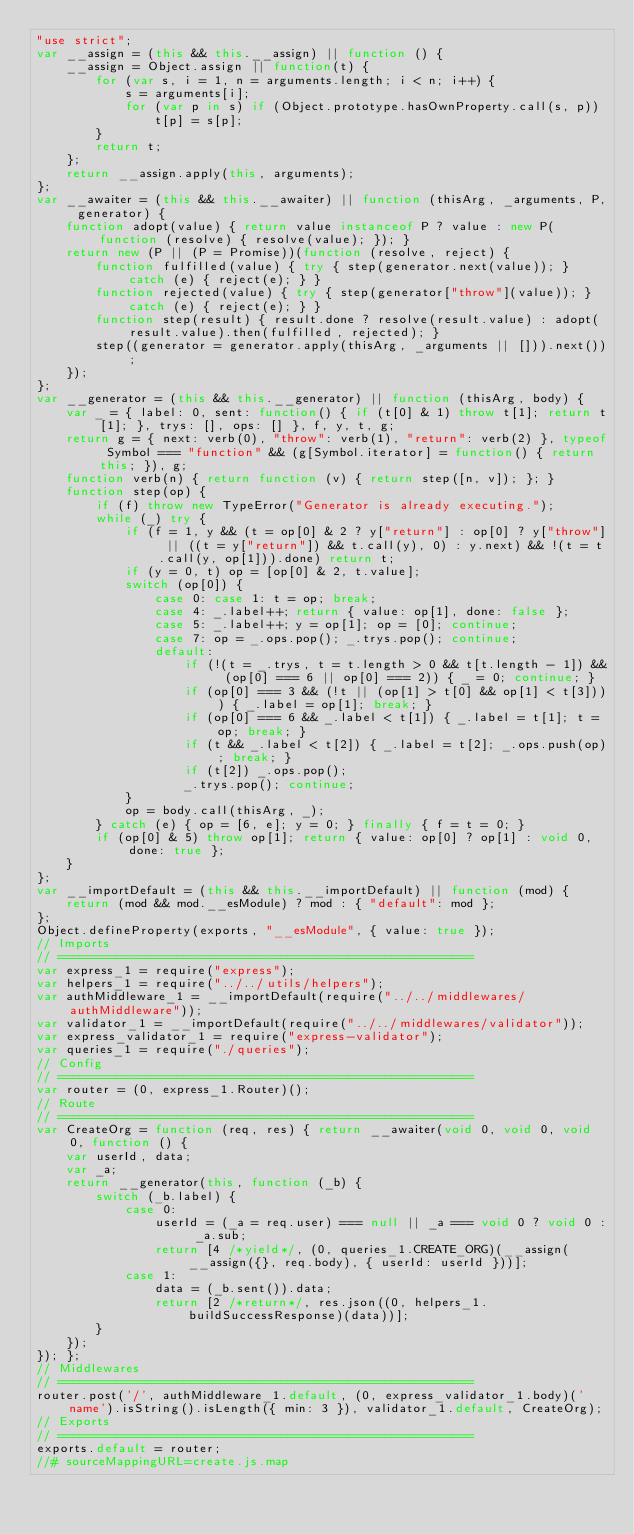<code> <loc_0><loc_0><loc_500><loc_500><_JavaScript_>"use strict";
var __assign = (this && this.__assign) || function () {
    __assign = Object.assign || function(t) {
        for (var s, i = 1, n = arguments.length; i < n; i++) {
            s = arguments[i];
            for (var p in s) if (Object.prototype.hasOwnProperty.call(s, p))
                t[p] = s[p];
        }
        return t;
    };
    return __assign.apply(this, arguments);
};
var __awaiter = (this && this.__awaiter) || function (thisArg, _arguments, P, generator) {
    function adopt(value) { return value instanceof P ? value : new P(function (resolve) { resolve(value); }); }
    return new (P || (P = Promise))(function (resolve, reject) {
        function fulfilled(value) { try { step(generator.next(value)); } catch (e) { reject(e); } }
        function rejected(value) { try { step(generator["throw"](value)); } catch (e) { reject(e); } }
        function step(result) { result.done ? resolve(result.value) : adopt(result.value).then(fulfilled, rejected); }
        step((generator = generator.apply(thisArg, _arguments || [])).next());
    });
};
var __generator = (this && this.__generator) || function (thisArg, body) {
    var _ = { label: 0, sent: function() { if (t[0] & 1) throw t[1]; return t[1]; }, trys: [], ops: [] }, f, y, t, g;
    return g = { next: verb(0), "throw": verb(1), "return": verb(2) }, typeof Symbol === "function" && (g[Symbol.iterator] = function() { return this; }), g;
    function verb(n) { return function (v) { return step([n, v]); }; }
    function step(op) {
        if (f) throw new TypeError("Generator is already executing.");
        while (_) try {
            if (f = 1, y && (t = op[0] & 2 ? y["return"] : op[0] ? y["throw"] || ((t = y["return"]) && t.call(y), 0) : y.next) && !(t = t.call(y, op[1])).done) return t;
            if (y = 0, t) op = [op[0] & 2, t.value];
            switch (op[0]) {
                case 0: case 1: t = op; break;
                case 4: _.label++; return { value: op[1], done: false };
                case 5: _.label++; y = op[1]; op = [0]; continue;
                case 7: op = _.ops.pop(); _.trys.pop(); continue;
                default:
                    if (!(t = _.trys, t = t.length > 0 && t[t.length - 1]) && (op[0] === 6 || op[0] === 2)) { _ = 0; continue; }
                    if (op[0] === 3 && (!t || (op[1] > t[0] && op[1] < t[3]))) { _.label = op[1]; break; }
                    if (op[0] === 6 && _.label < t[1]) { _.label = t[1]; t = op; break; }
                    if (t && _.label < t[2]) { _.label = t[2]; _.ops.push(op); break; }
                    if (t[2]) _.ops.pop();
                    _.trys.pop(); continue;
            }
            op = body.call(thisArg, _);
        } catch (e) { op = [6, e]; y = 0; } finally { f = t = 0; }
        if (op[0] & 5) throw op[1]; return { value: op[0] ? op[1] : void 0, done: true };
    }
};
var __importDefault = (this && this.__importDefault) || function (mod) {
    return (mod && mod.__esModule) ? mod : { "default": mod };
};
Object.defineProperty(exports, "__esModule", { value: true });
// Imports
// ========================================================
var express_1 = require("express");
var helpers_1 = require("../../utils/helpers");
var authMiddleware_1 = __importDefault(require("../../middlewares/authMiddleware"));
var validator_1 = __importDefault(require("../../middlewares/validator"));
var express_validator_1 = require("express-validator");
var queries_1 = require("./queries");
// Config
// ========================================================
var router = (0, express_1.Router)();
// Route
// ========================================================
var CreateOrg = function (req, res) { return __awaiter(void 0, void 0, void 0, function () {
    var userId, data;
    var _a;
    return __generator(this, function (_b) {
        switch (_b.label) {
            case 0:
                userId = (_a = req.user) === null || _a === void 0 ? void 0 : _a.sub;
                return [4 /*yield*/, (0, queries_1.CREATE_ORG)(__assign(__assign({}, req.body), { userId: userId }))];
            case 1:
                data = (_b.sent()).data;
                return [2 /*return*/, res.json((0, helpers_1.buildSuccessResponse)(data))];
        }
    });
}); };
// Middlewares
// ========================================================
router.post('/', authMiddleware_1.default, (0, express_validator_1.body)('name').isString().isLength({ min: 3 }), validator_1.default, CreateOrg);
// Exports
// ========================================================
exports.default = router;
//# sourceMappingURL=create.js.map</code> 